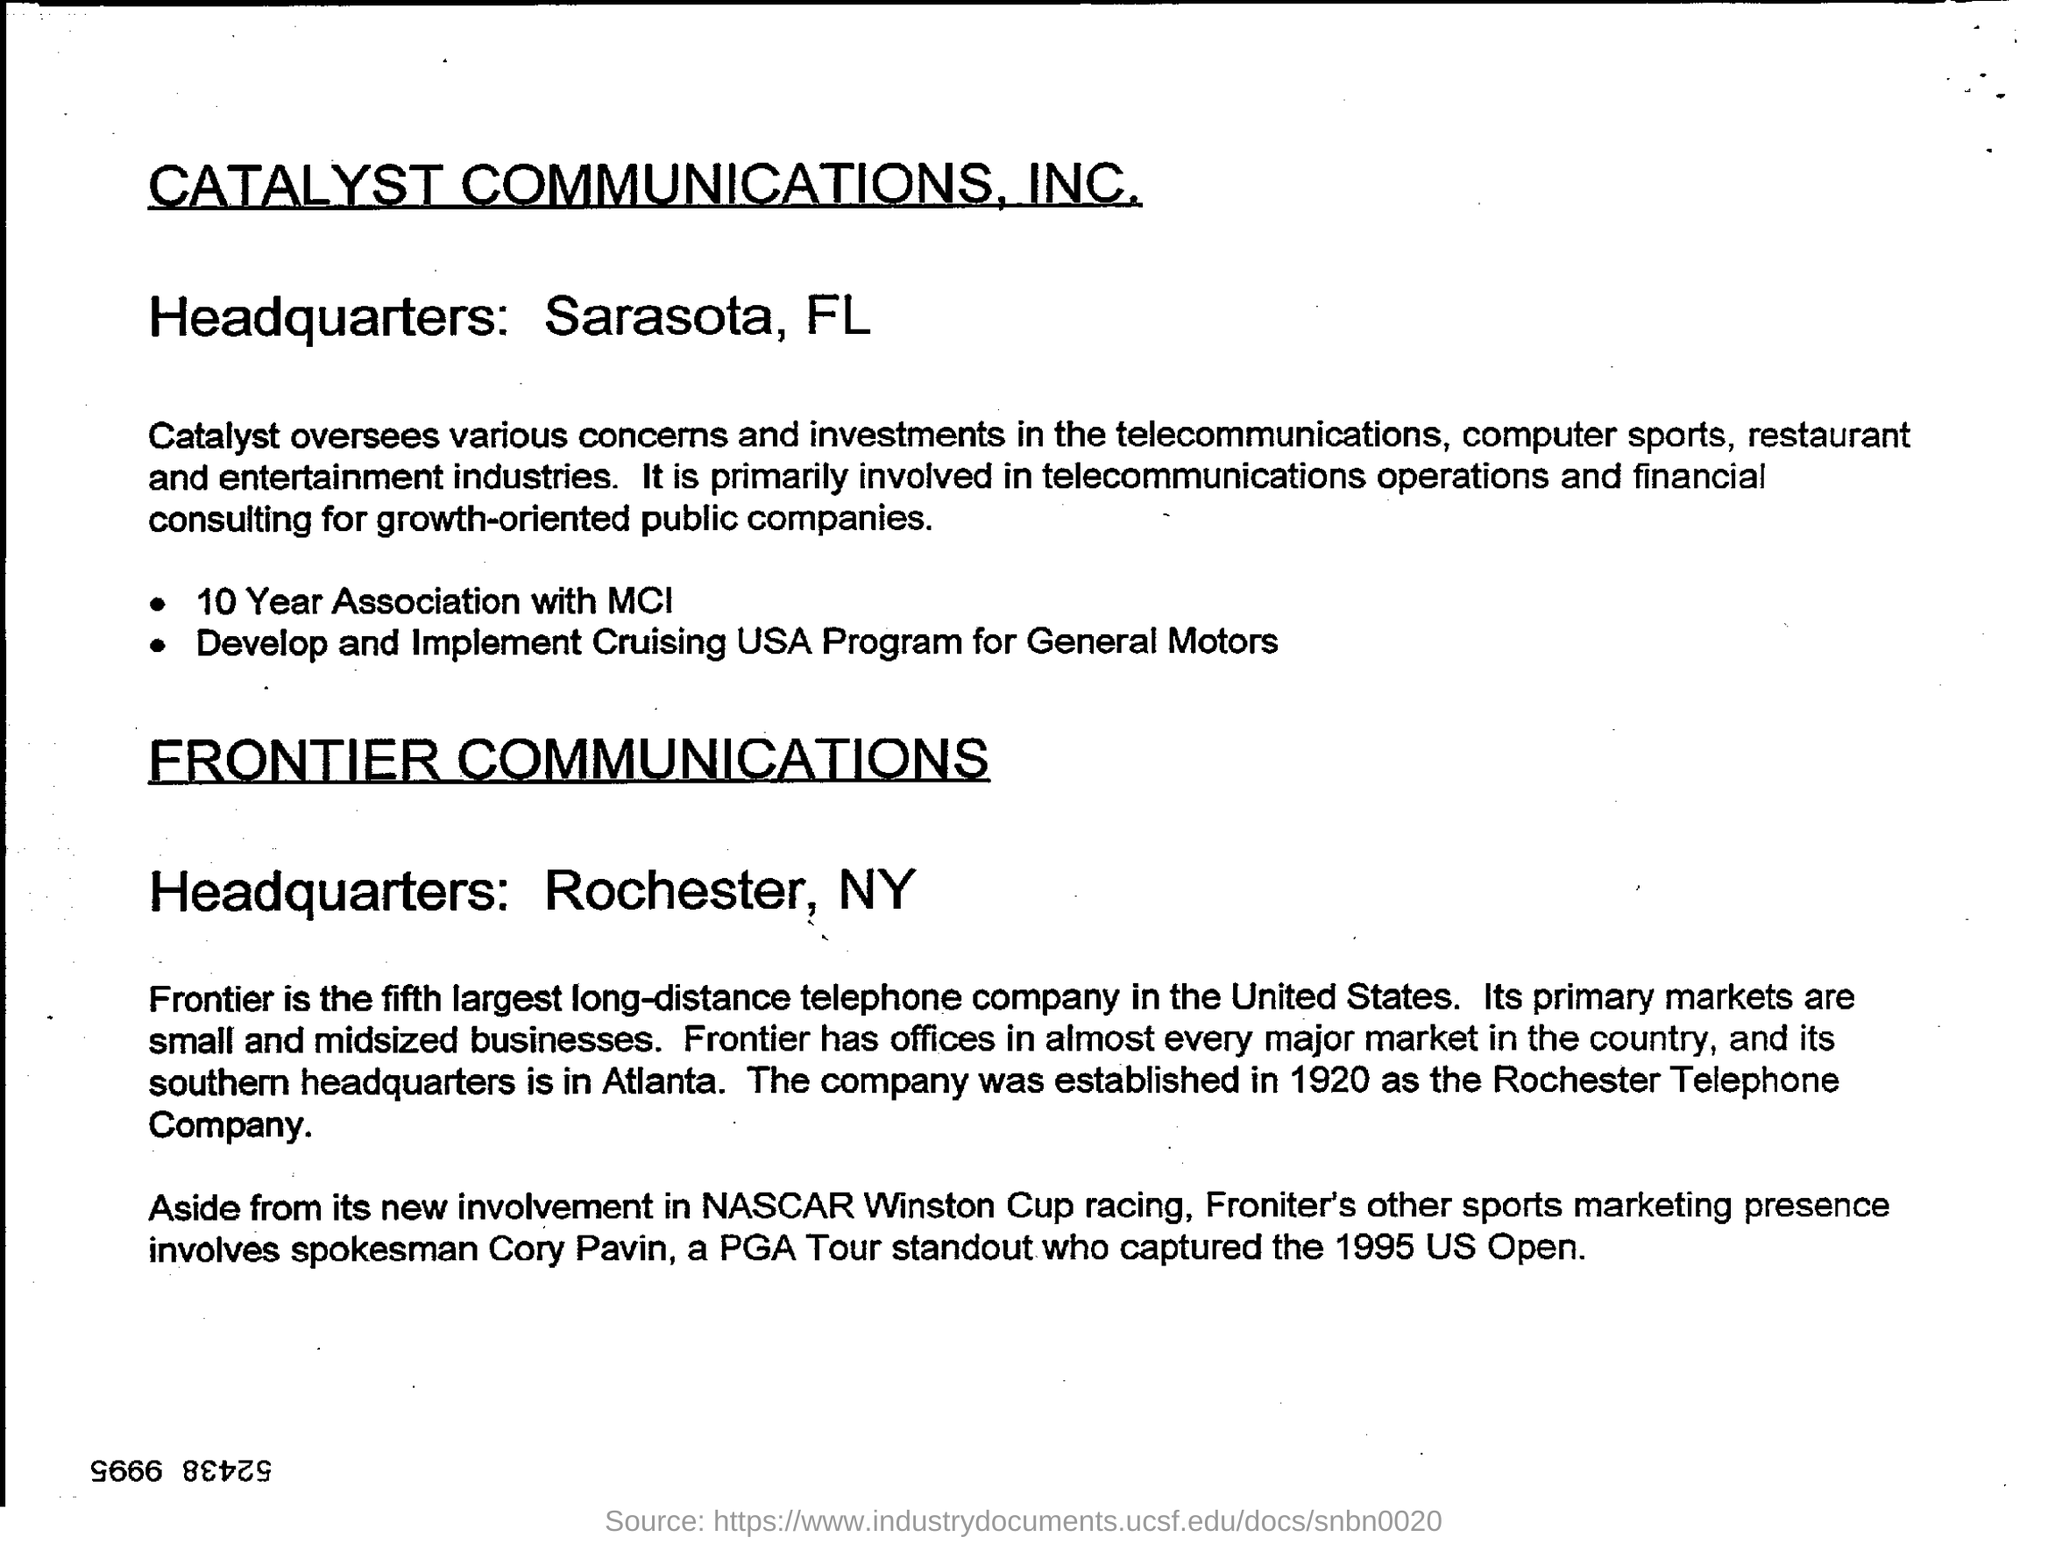List a handful of essential elements in this visual. Catalyst Communications, INC is headquartered in Sarasota, Florida. Frontier Communications' headquarters is located in Rochester, New York. 